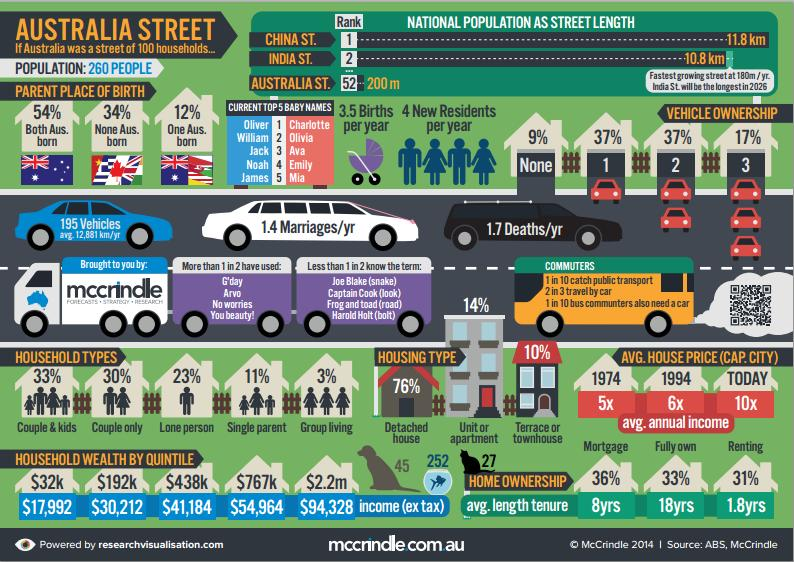Point out several critical features in this image. The third most popular name for girls in the top 5 is Ava. According to the data, 17% of people own three vehicles or more. Approximately 3% of households have group living arrangements. According to recent data, approximately 10% of houses in a particular area are terrace or townhouses. Approximately 37% of people own just one vehicle. 